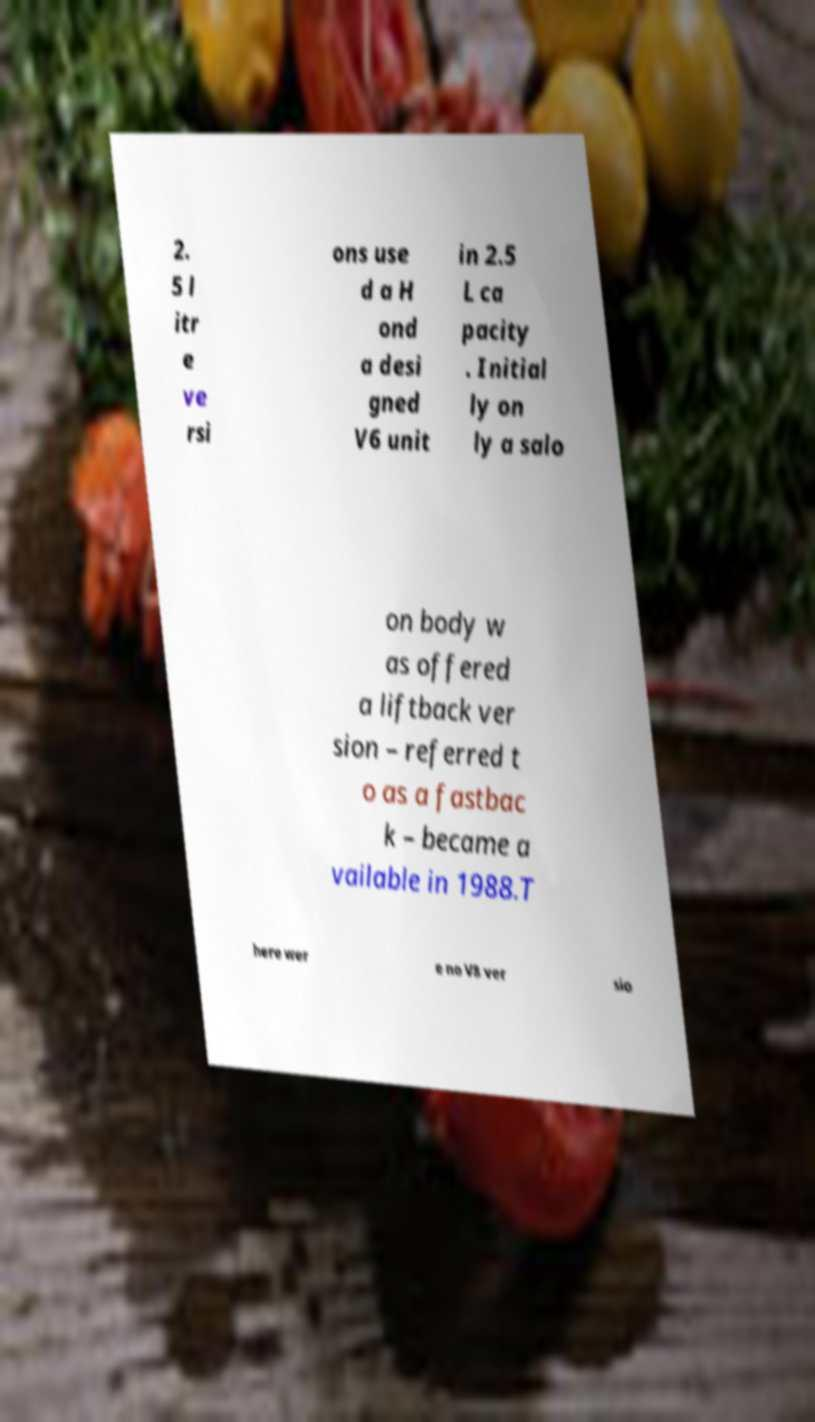Can you read and provide the text displayed in the image?This photo seems to have some interesting text. Can you extract and type it out for me? 2. 5 l itr e ve rsi ons use d a H ond a desi gned V6 unit in 2.5 L ca pacity . Initial ly on ly a salo on body w as offered a liftback ver sion – referred t o as a fastbac k – became a vailable in 1988.T here wer e no V8 ver sio 